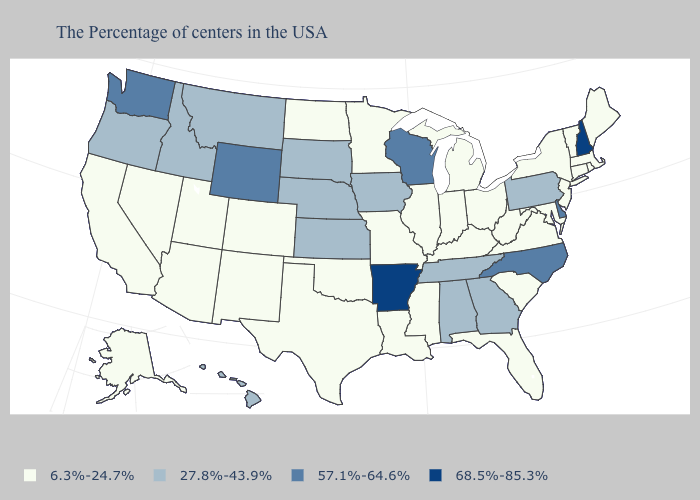Does Mississippi have the lowest value in the South?
Concise answer only. Yes. Name the states that have a value in the range 6.3%-24.7%?
Answer briefly. Maine, Massachusetts, Rhode Island, Vermont, Connecticut, New York, New Jersey, Maryland, Virginia, South Carolina, West Virginia, Ohio, Florida, Michigan, Kentucky, Indiana, Illinois, Mississippi, Louisiana, Missouri, Minnesota, Oklahoma, Texas, North Dakota, Colorado, New Mexico, Utah, Arizona, Nevada, California, Alaska. Does the first symbol in the legend represent the smallest category?
Short answer required. Yes. Name the states that have a value in the range 27.8%-43.9%?
Short answer required. Pennsylvania, Georgia, Alabama, Tennessee, Iowa, Kansas, Nebraska, South Dakota, Montana, Idaho, Oregon, Hawaii. What is the value of Oklahoma?
Be succinct. 6.3%-24.7%. What is the value of Tennessee?
Write a very short answer. 27.8%-43.9%. Name the states that have a value in the range 27.8%-43.9%?
Be succinct. Pennsylvania, Georgia, Alabama, Tennessee, Iowa, Kansas, Nebraska, South Dakota, Montana, Idaho, Oregon, Hawaii. What is the highest value in the Northeast ?
Quick response, please. 68.5%-85.3%. Which states have the lowest value in the USA?
Give a very brief answer. Maine, Massachusetts, Rhode Island, Vermont, Connecticut, New York, New Jersey, Maryland, Virginia, South Carolina, West Virginia, Ohio, Florida, Michigan, Kentucky, Indiana, Illinois, Mississippi, Louisiana, Missouri, Minnesota, Oklahoma, Texas, North Dakota, Colorado, New Mexico, Utah, Arizona, Nevada, California, Alaska. Name the states that have a value in the range 27.8%-43.9%?
Concise answer only. Pennsylvania, Georgia, Alabama, Tennessee, Iowa, Kansas, Nebraska, South Dakota, Montana, Idaho, Oregon, Hawaii. Which states have the lowest value in the USA?
Write a very short answer. Maine, Massachusetts, Rhode Island, Vermont, Connecticut, New York, New Jersey, Maryland, Virginia, South Carolina, West Virginia, Ohio, Florida, Michigan, Kentucky, Indiana, Illinois, Mississippi, Louisiana, Missouri, Minnesota, Oklahoma, Texas, North Dakota, Colorado, New Mexico, Utah, Arizona, Nevada, California, Alaska. Name the states that have a value in the range 27.8%-43.9%?
Keep it brief. Pennsylvania, Georgia, Alabama, Tennessee, Iowa, Kansas, Nebraska, South Dakota, Montana, Idaho, Oregon, Hawaii. Which states have the lowest value in the USA?
Give a very brief answer. Maine, Massachusetts, Rhode Island, Vermont, Connecticut, New York, New Jersey, Maryland, Virginia, South Carolina, West Virginia, Ohio, Florida, Michigan, Kentucky, Indiana, Illinois, Mississippi, Louisiana, Missouri, Minnesota, Oklahoma, Texas, North Dakota, Colorado, New Mexico, Utah, Arizona, Nevada, California, Alaska. Does the map have missing data?
Keep it brief. No. Name the states that have a value in the range 6.3%-24.7%?
Be succinct. Maine, Massachusetts, Rhode Island, Vermont, Connecticut, New York, New Jersey, Maryland, Virginia, South Carolina, West Virginia, Ohio, Florida, Michigan, Kentucky, Indiana, Illinois, Mississippi, Louisiana, Missouri, Minnesota, Oklahoma, Texas, North Dakota, Colorado, New Mexico, Utah, Arizona, Nevada, California, Alaska. 